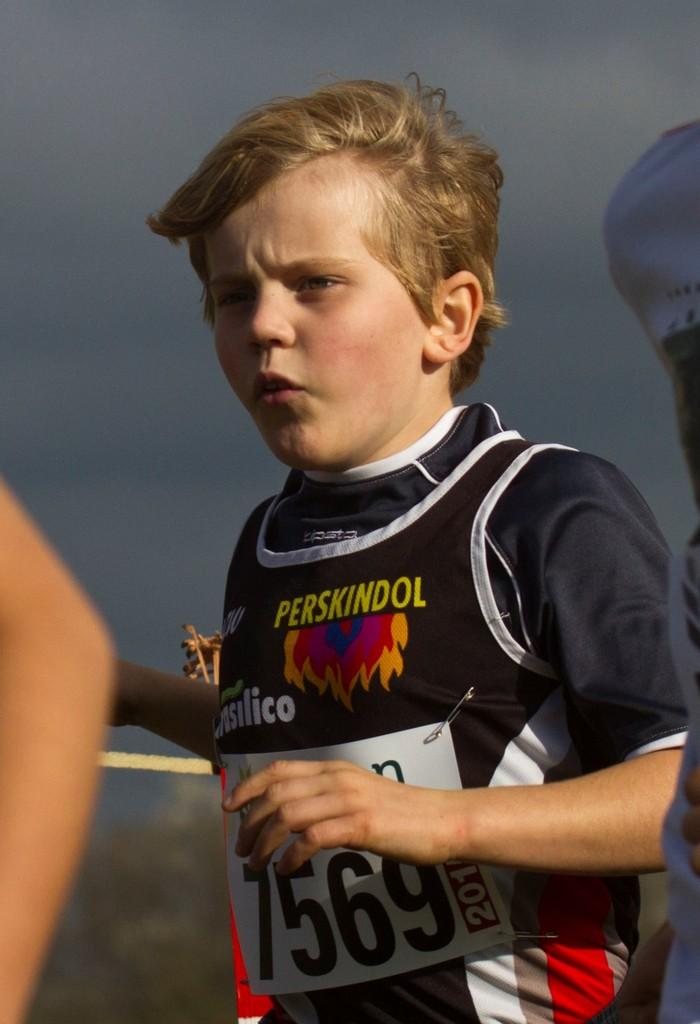<image>
Relay a brief, clear account of the picture shown. A small boy has a marathon runner shirt with the number 7569 on his mid section. 